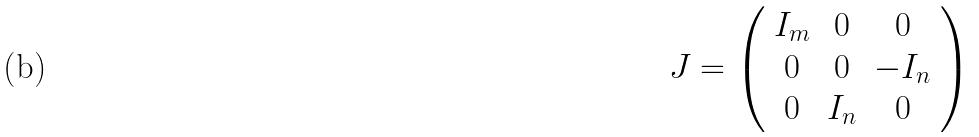<formula> <loc_0><loc_0><loc_500><loc_500>J = \left ( \begin{array} { c c c } I _ { m } & 0 & 0 \\ 0 & 0 & - I _ { n } \\ 0 & I _ { n } & 0 \end{array} \right )</formula> 